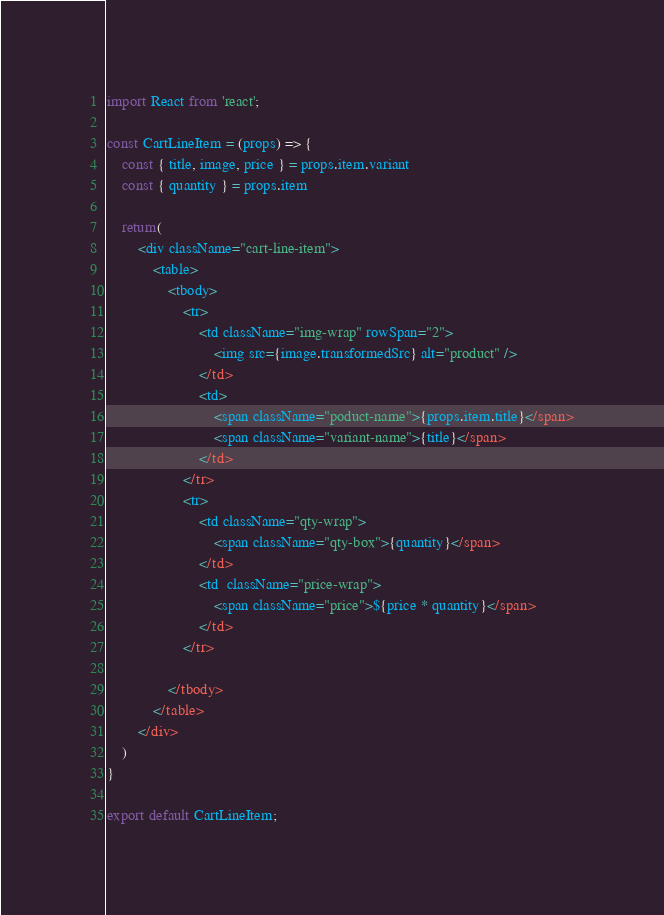Convert code to text. <code><loc_0><loc_0><loc_500><loc_500><_JavaScript_>import React from 'react';

const CartLineItem = (props) => {
	const { title, image, price } = props.item.variant
	const { quantity } = props.item

	return(
		<div className="cart-line-item">
			<table>
				<tbody>
					<tr>
						<td className="img-wrap" rowSpan="2">
							<img src={image.transformedSrc} alt="product" />
						</td>
						<td>
							<span className="poduct-name">{props.item.title}</span>
							<span className="variant-name">{title}</span>
						</td>
					</tr>
					<tr>
						<td className="qty-wrap">
							<span className="qty-box">{quantity}</span>
						</td>
						<td  className="price-wrap">
							<span className="price">${price * quantity}</span>
						</td>
					</tr>

				</tbody>
			</table>
		</div>
	)
}

export default CartLineItem;</code> 